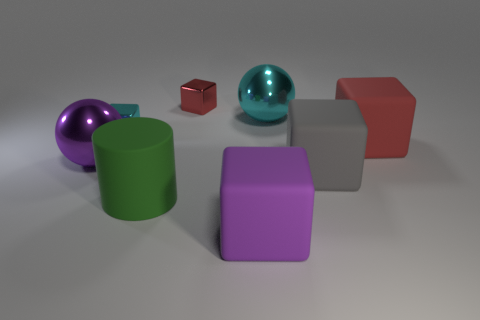Subtract all tiny cyan cubes. How many cubes are left? 4 Add 2 large brown things. How many objects exist? 10 Subtract all cyan blocks. How many blocks are left? 4 Subtract all balls. How many objects are left? 6 Subtract 1 spheres. How many spheres are left? 1 Subtract 0 red cylinders. How many objects are left? 8 Subtract all brown blocks. Subtract all purple cylinders. How many blocks are left? 5 Subtract all cyan cylinders. How many cyan spheres are left? 1 Subtract all balls. Subtract all tiny blue shiny cylinders. How many objects are left? 6 Add 3 red metal objects. How many red metal objects are left? 4 